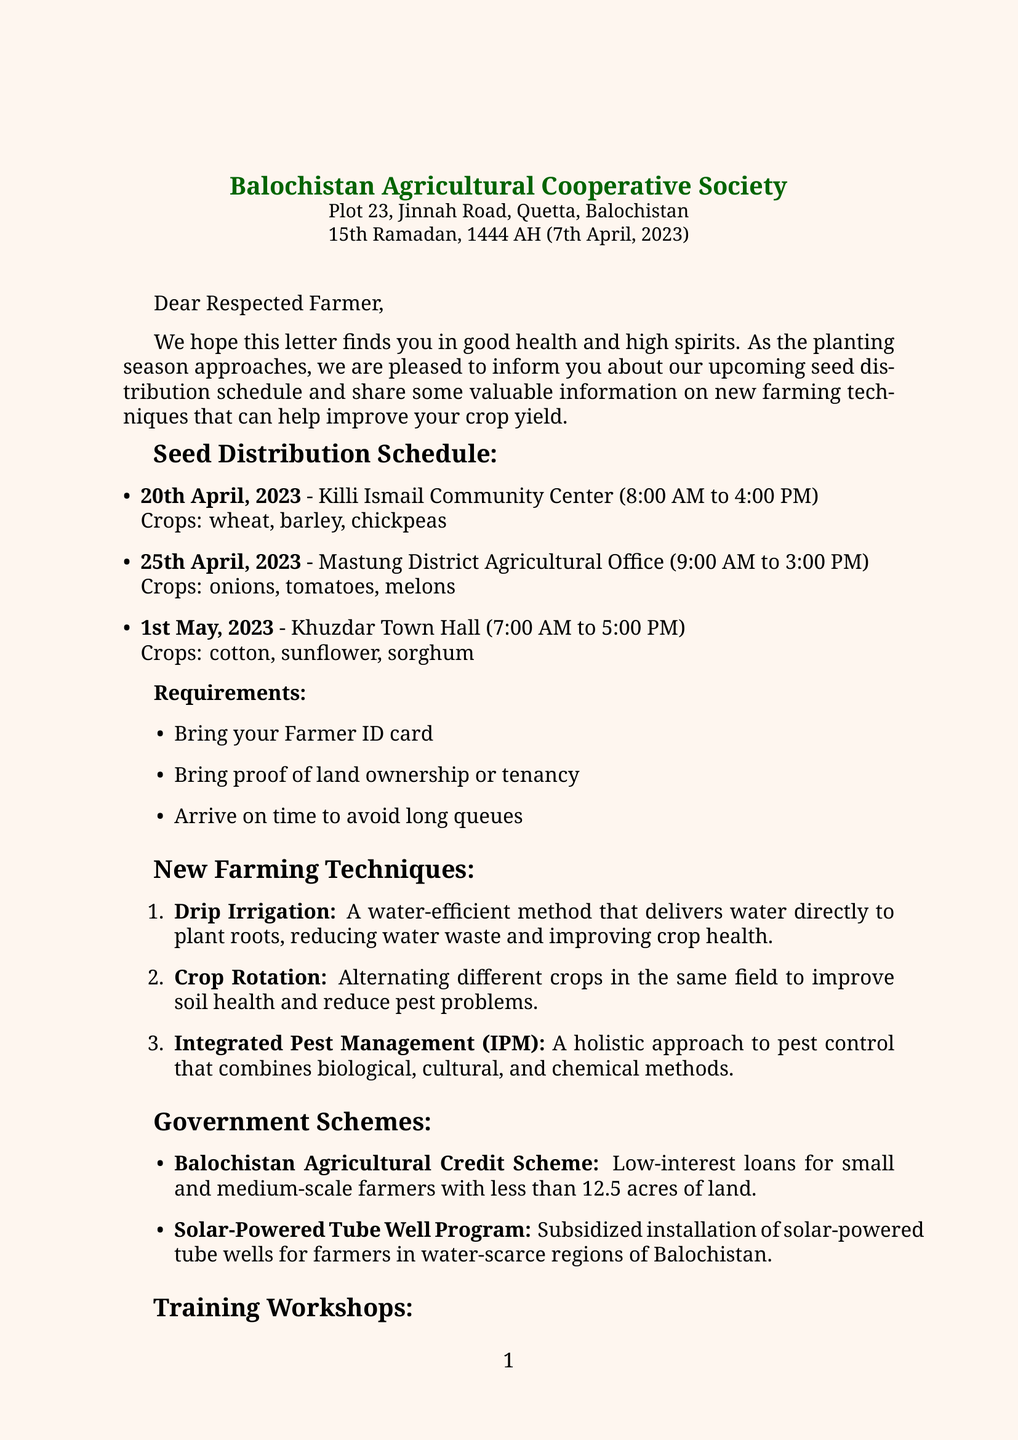What is the name of the cooperative? The name of the cooperative is mentioned in the letter header.
Answer: Balochistan Agricultural Cooperative Society What date is the seed distribution at Killi Ismail Community Center? The date for the seed distribution at this location is specified in the schedule.
Answer: 20th April, 2023 What crops will be distributed on 25th April? The crops are listed under the schedule for this date.
Answer: onions, tomatoes, melons What are the requirements to collect seeds? The letter lists the necessary items to bring when attending the seed distribution.
Answer: Farmer ID card, proof of land ownership or tenancy, arrive on time to avoid long queues How many workshops are mentioned in the letter? The total number of workshops is calculated from the training workshops section.
Answer: 2 What is one benefit of Drip Irrigation? The benefits are provided under each new farming technique described in the document.
Answer: Water conservation Who is the contact person for the cooperative? The letter includes a signature section stating the individual responsible for communication.
Answer: Abdul Qadir Baloch When is the workshop on Climate-Smart Agriculture scheduled? The specific date is mentioned under the training workshops section.
Answer: 15th May, 2023 What is the duration of the Organic Farming Practices workshop? The duration of this workshop is stated in the details provided.
Answer: One-day workshop 